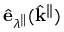Convert formula to latex. <formula><loc_0><loc_0><loc_500><loc_500>\hat { e } _ { \lambda ^ { \| } } ( \hat { k } ^ { \| } )</formula> 